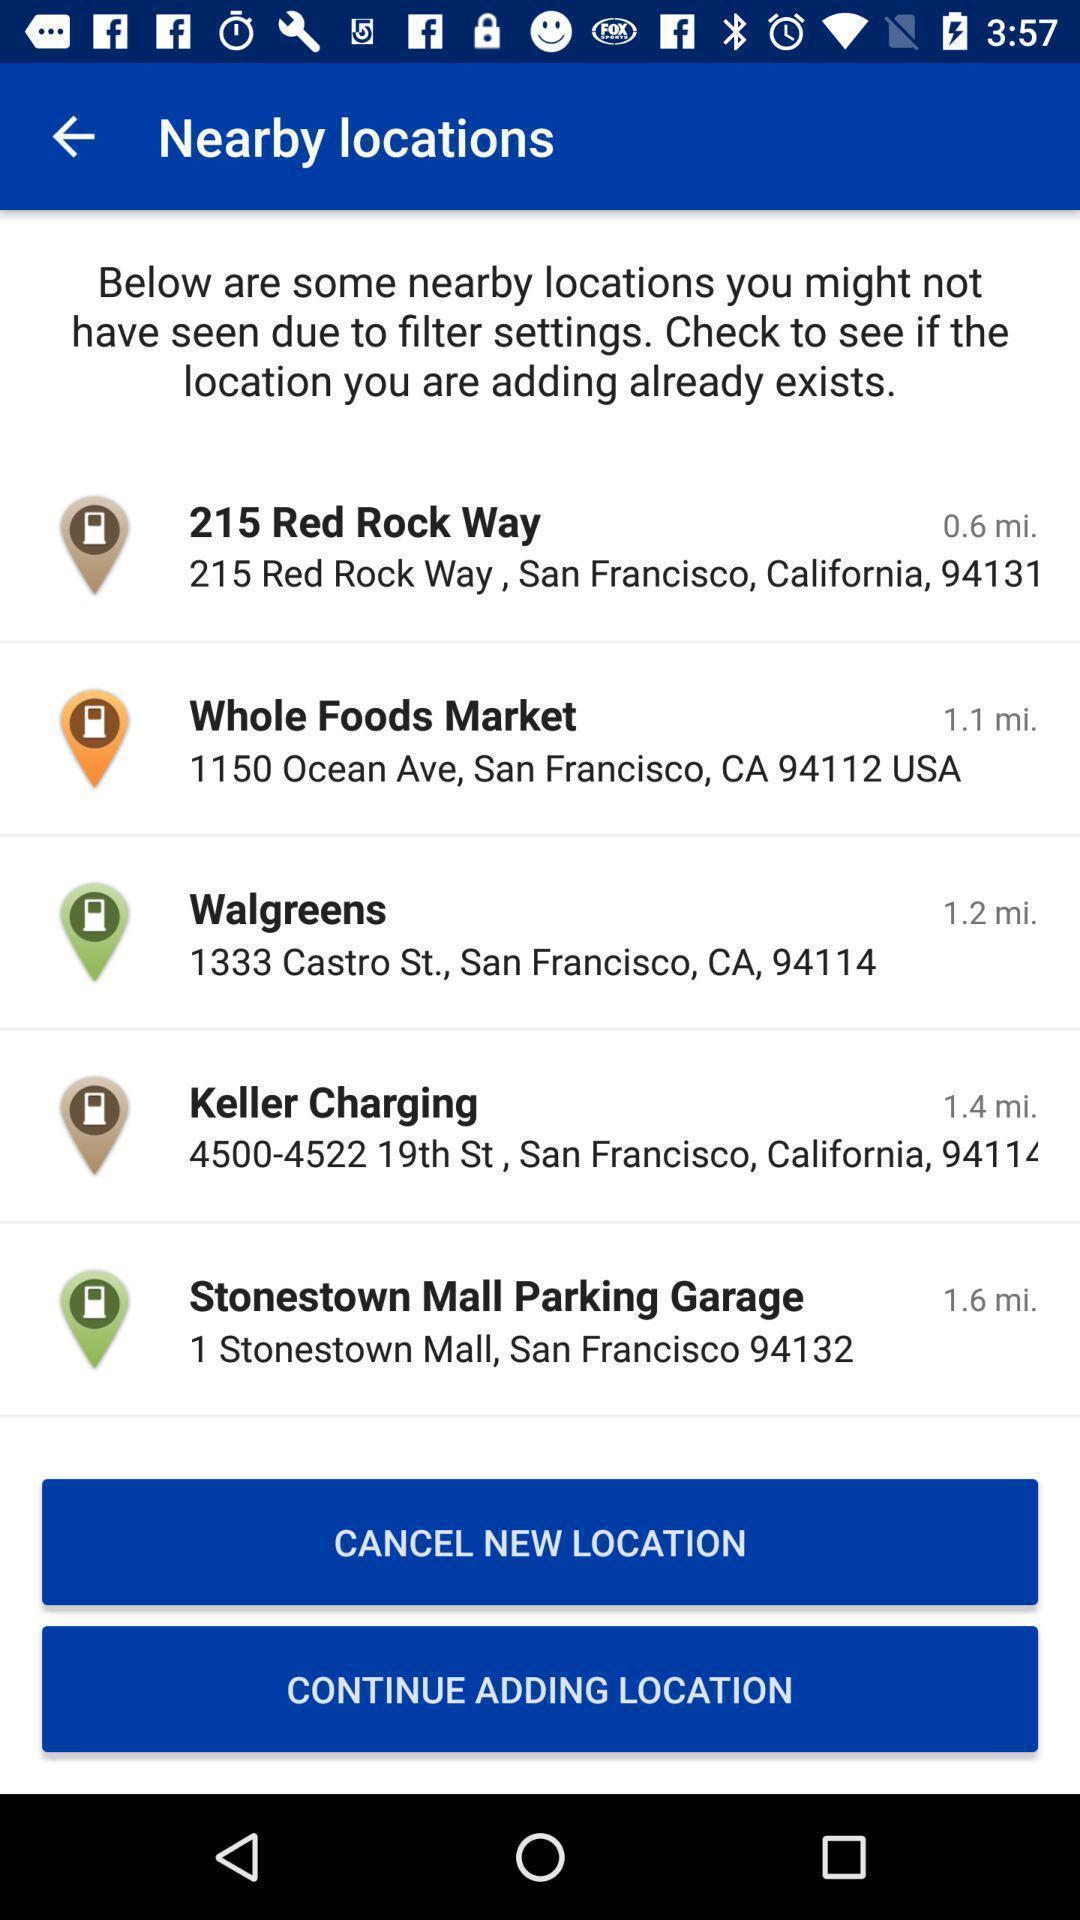Describe the key features of this screenshot. Page displaying with list of locations and few options. 